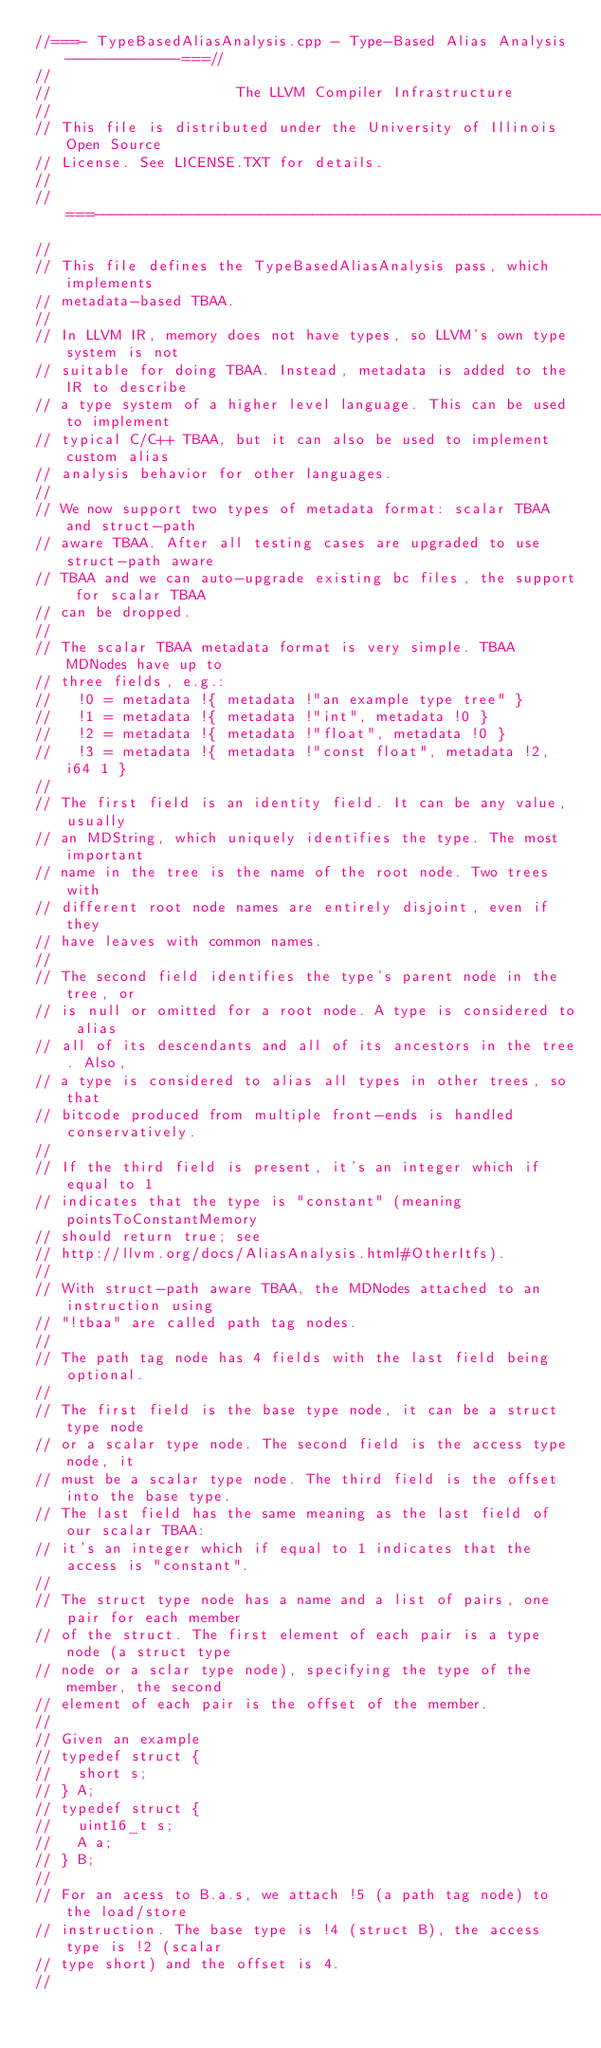<code> <loc_0><loc_0><loc_500><loc_500><_C++_>//===- TypeBasedAliasAnalysis.cpp - Type-Based Alias Analysis -------------===//
//
//                     The LLVM Compiler Infrastructure
//
// This file is distributed under the University of Illinois Open Source
// License. See LICENSE.TXT for details.
//
//===----------------------------------------------------------------------===//
//
// This file defines the TypeBasedAliasAnalysis pass, which implements
// metadata-based TBAA.
//
// In LLVM IR, memory does not have types, so LLVM's own type system is not
// suitable for doing TBAA. Instead, metadata is added to the IR to describe
// a type system of a higher level language. This can be used to implement
// typical C/C++ TBAA, but it can also be used to implement custom alias
// analysis behavior for other languages.
//
// We now support two types of metadata format: scalar TBAA and struct-path
// aware TBAA. After all testing cases are upgraded to use struct-path aware
// TBAA and we can auto-upgrade existing bc files, the support for scalar TBAA
// can be dropped.
//
// The scalar TBAA metadata format is very simple. TBAA MDNodes have up to
// three fields, e.g.:
//   !0 = metadata !{ metadata !"an example type tree" }
//   !1 = metadata !{ metadata !"int", metadata !0 }
//   !2 = metadata !{ metadata !"float", metadata !0 }
//   !3 = metadata !{ metadata !"const float", metadata !2, i64 1 }
//
// The first field is an identity field. It can be any value, usually
// an MDString, which uniquely identifies the type. The most important
// name in the tree is the name of the root node. Two trees with
// different root node names are entirely disjoint, even if they
// have leaves with common names.
//
// The second field identifies the type's parent node in the tree, or
// is null or omitted for a root node. A type is considered to alias
// all of its descendants and all of its ancestors in the tree. Also,
// a type is considered to alias all types in other trees, so that
// bitcode produced from multiple front-ends is handled conservatively.
//
// If the third field is present, it's an integer which if equal to 1
// indicates that the type is "constant" (meaning pointsToConstantMemory
// should return true; see
// http://llvm.org/docs/AliasAnalysis.html#OtherItfs).
//
// With struct-path aware TBAA, the MDNodes attached to an instruction using
// "!tbaa" are called path tag nodes.
//
// The path tag node has 4 fields with the last field being optional.
//
// The first field is the base type node, it can be a struct type node
// or a scalar type node. The second field is the access type node, it
// must be a scalar type node. The third field is the offset into the base type.
// The last field has the same meaning as the last field of our scalar TBAA:
// it's an integer which if equal to 1 indicates that the access is "constant".
//
// The struct type node has a name and a list of pairs, one pair for each member
// of the struct. The first element of each pair is a type node (a struct type
// node or a sclar type node), specifying the type of the member, the second
// element of each pair is the offset of the member.
//
// Given an example
// typedef struct {
//   short s;
// } A;
// typedef struct {
//   uint16_t s;
//   A a;
// } B;
//
// For an acess to B.a.s, we attach !5 (a path tag node) to the load/store
// instruction. The base type is !4 (struct B), the access type is !2 (scalar
// type short) and the offset is 4.
//</code> 